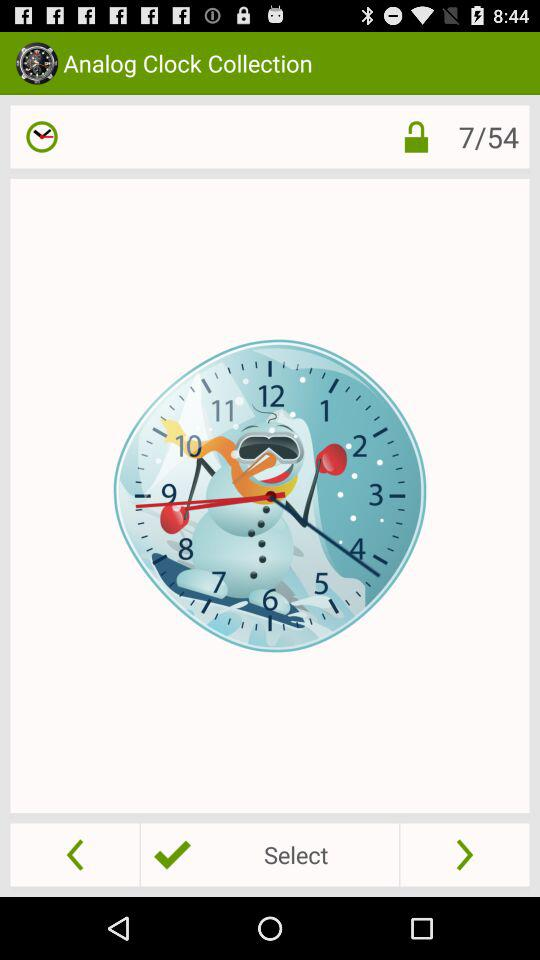What is the name of the application? The name of the application is "Analog Clock Collection". 